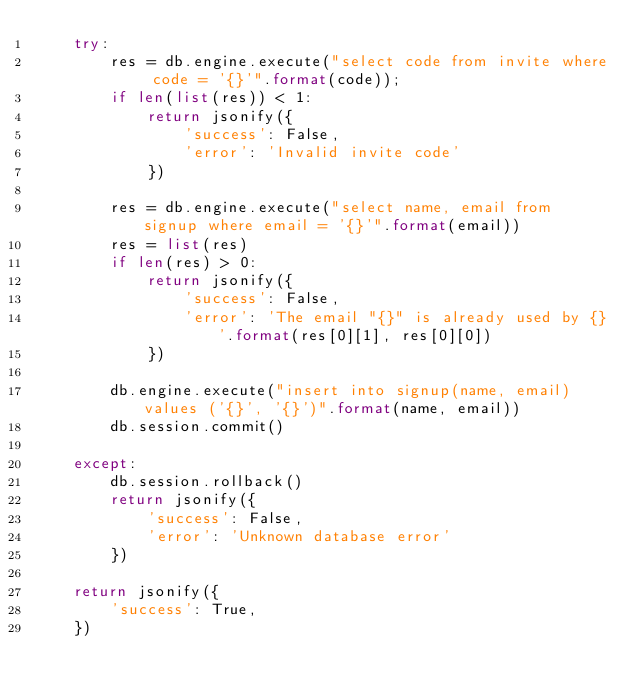<code> <loc_0><loc_0><loc_500><loc_500><_Python_>    try:
        res = db.engine.execute("select code from invite where code = '{}'".format(code));
        if len(list(res)) < 1:
            return jsonify({
                'success': False,
                'error': 'Invalid invite code'
            })

        res = db.engine.execute("select name, email from signup where email = '{}'".format(email))
        res = list(res)
        if len(res) > 0:
            return jsonify({
                'success': False,
                'error': 'The email "{}" is already used by {}'.format(res[0][1], res[0][0])
            })

        db.engine.execute("insert into signup(name, email) values ('{}', '{}')".format(name, email))
        db.session.commit()

    except:
        db.session.rollback()
        return jsonify({
            'success': False,
            'error': 'Unknown database error'
        })

    return jsonify({
        'success': True,
    })
</code> 